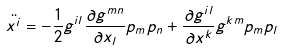<formula> <loc_0><loc_0><loc_500><loc_500>\ddot { x ^ { i } } = - \frac { 1 } { 2 } g ^ { i l } \frac { \partial g ^ { m n } } { \partial x _ { l } } p _ { m } p _ { n } + \frac { \partial g ^ { i l } } { \partial x ^ { k } } g ^ { k m } p _ { m } p _ { l }</formula> 